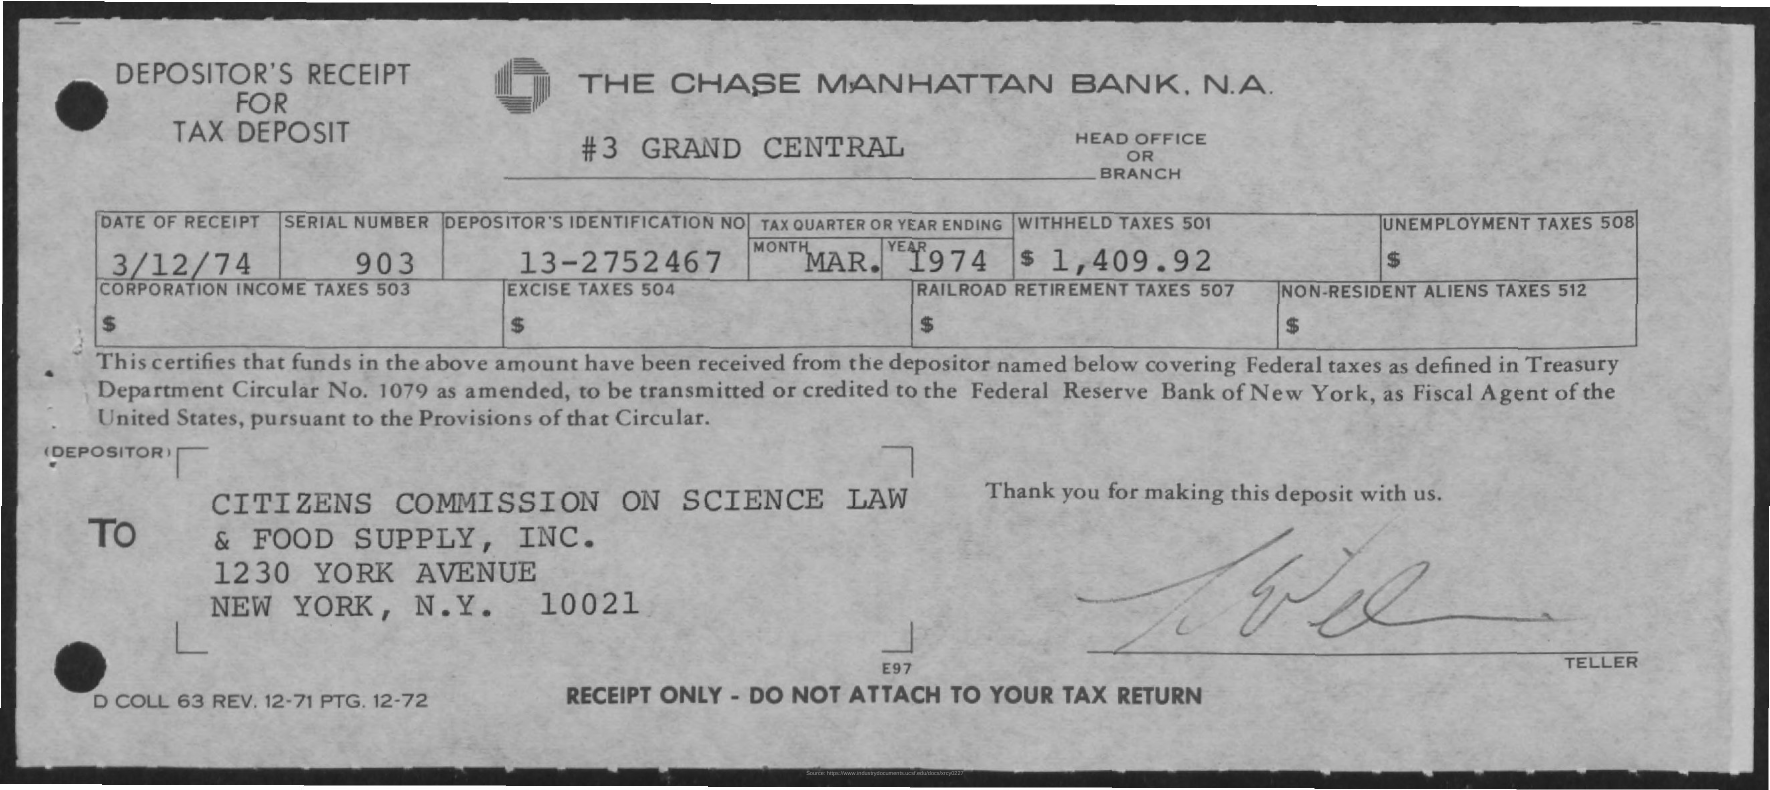What is the name of the bank
Your answer should be compact. The Chase Manhattan Bank. Where is the headoffice or branch located ?
Provide a short and direct response. #3 Grand Central. What is the date of receipt
Keep it short and to the point. 3/12/74. What is the serial number
Offer a very short reply. 903. What is the depositors identification no
Offer a terse response. 13-2752467. When is the tax quarter or year ending
Your answer should be very brief. Mar. 1974. How much is the withheld taxes 501
Keep it short and to the point. $ 1,409.92. Which city mentioned in the to address
Ensure brevity in your answer.  New york. What is the ZIP code given in the To address?
Your answer should be very brief. 10021. 